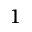Convert formula to latex. <formula><loc_0><loc_0><loc_500><loc_500>^ { 1 }</formula> 